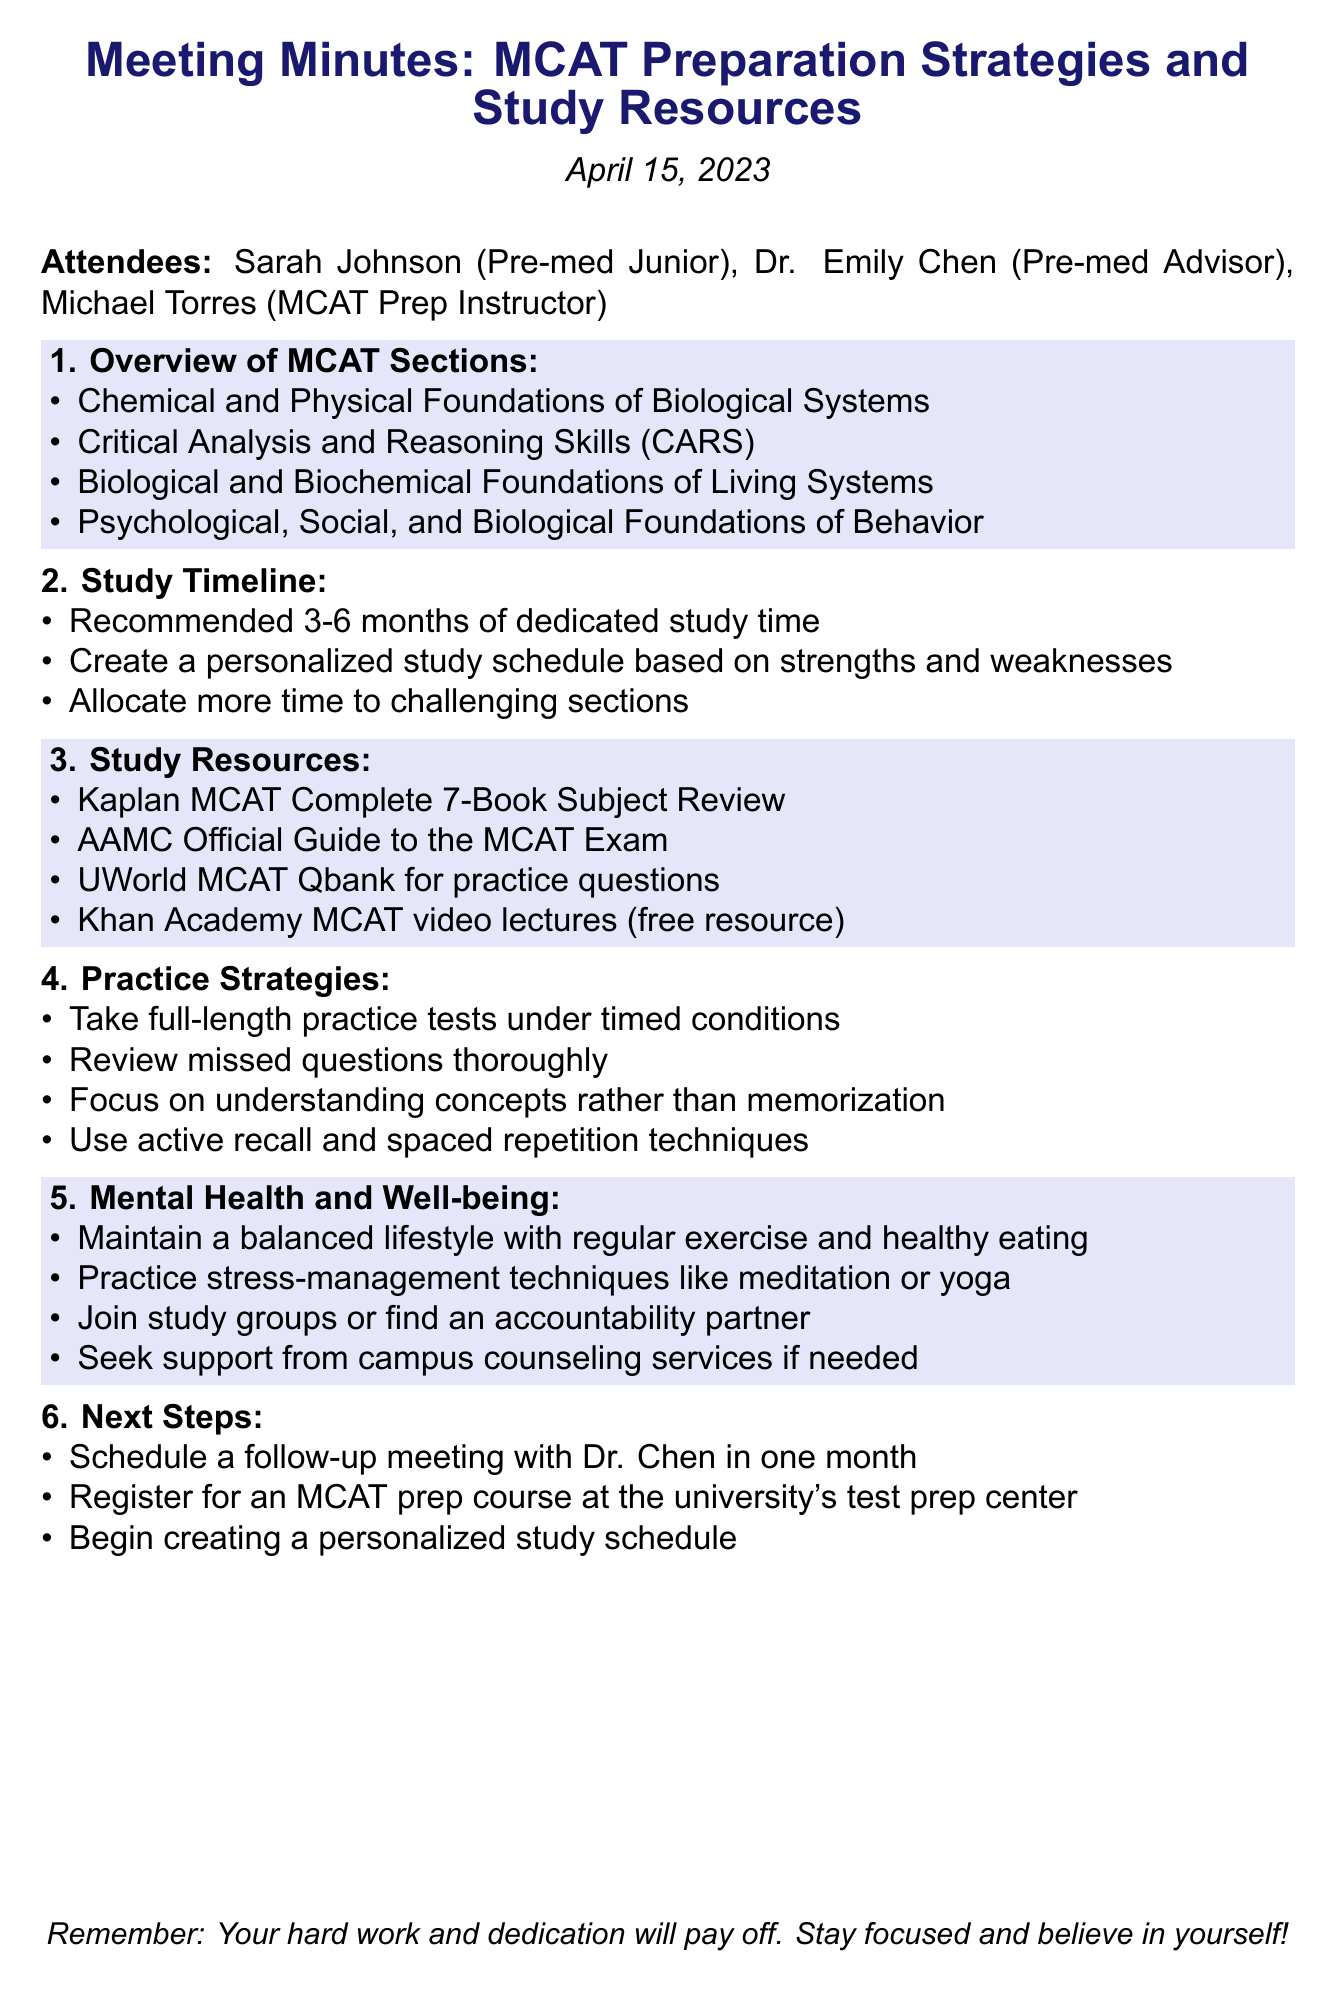What is the meeting title? The meeting title is stated at the beginning of the document, indicating the main focus of the discussion.
Answer: MCAT Preparation Strategies and Study Resources Who is the pre-med advisor? The document lists attendees, including their roles and names.
Answer: Dr. Emily Chen What is the recommended study time for the MCAT? The document specifies a range for dedicated study time that is suggested for effective preparation.
Answer: 3-6 months Which resource is mentioned as a free option for MCAT preparation? The document highlights various study resources, including one that is free.
Answer: Khan Academy MCAT video lectures What practice strategy involves reviewing missed questions? The document outlines practice strategies, including a specific method for improving performance.
Answer: Review missed questions thoroughly How many attendees were present at the meeting? The document lists the attendees who participated in the discussion.
Answer: 3 What is one of the next steps to be taken after the meeting? The document concludes with specific next steps that the attendees need to follow.
Answer: Schedule a follow-up meeting with Dr. Chen in one month What is a recommended technique for managing stress? The document includes suggestions for mental health and well-being, including strategies for stress management.
Answer: Meditation Which section is related to understanding human behavior? The document lists the sections of the MCAT, including one that focuses on behavior.
Answer: Psychological, Social, and Biological Foundations of Behavior 